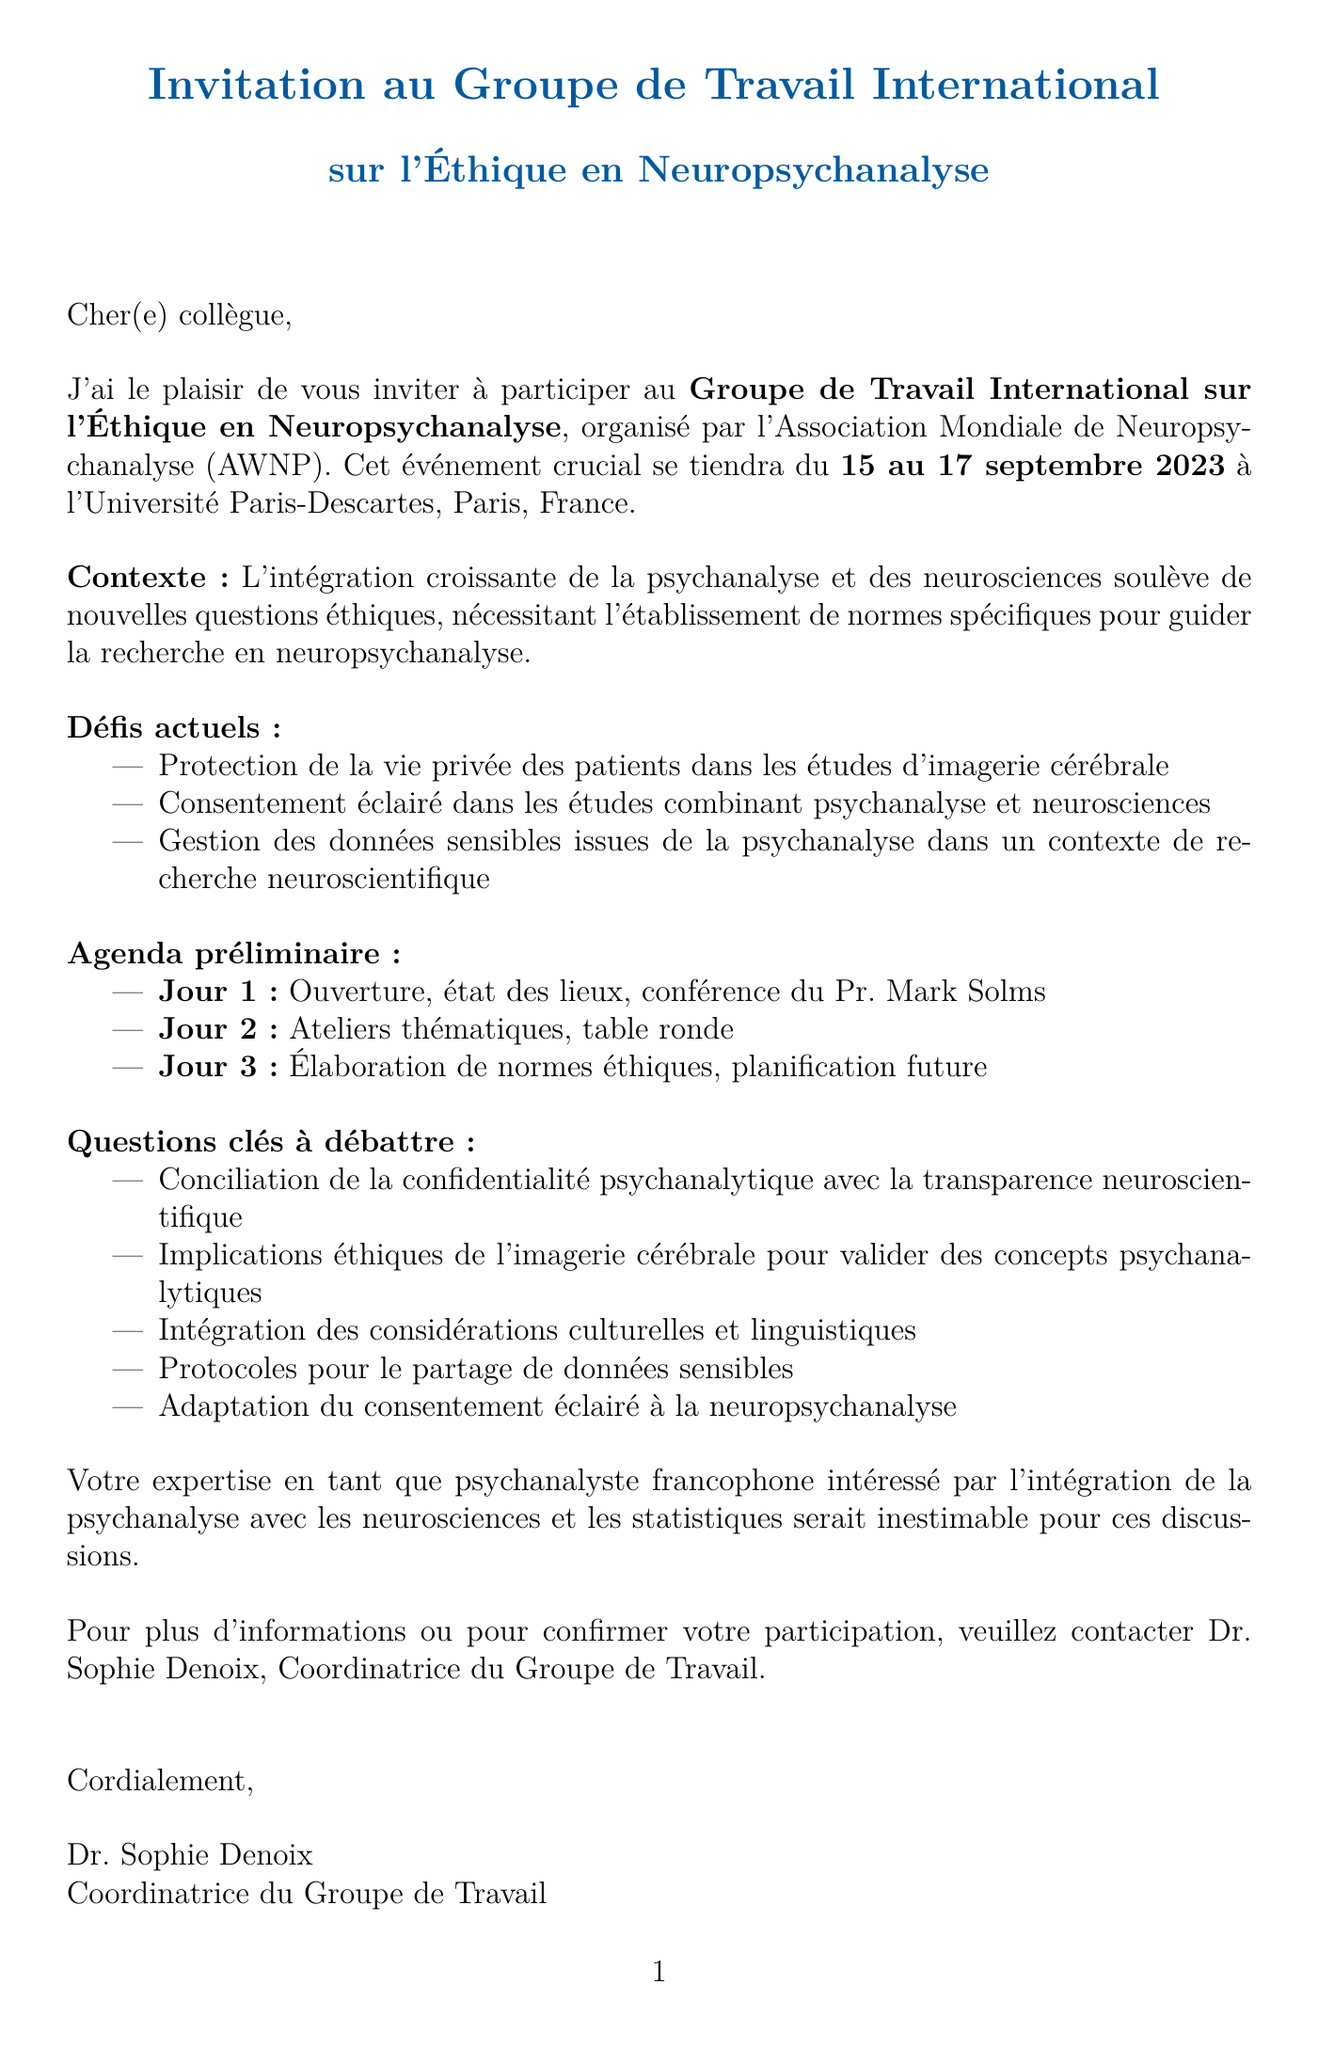Quel est le nom de l'événement ? Le nom de l'événement est mentionné dans le document comme étant le Groupe de Travail International sur l'Éthique en Neuropsychanalyse.
Answer: Groupe de Travail International sur l'Éthique en Neuropsychanalyse Qui est l'organisateur de l'événement ? L'organisateur de l'événement est précisé dans le document, c'est l'Association Mondiale de Neuropsychanalyse (AWNP).
Answer: Association Mondiale de Neuropsychanalyse (AWNP) Quand aura lieu l'événement ? La date de l'événement est spécifiée comme étant du 15 au 17 septembre 2023.
Answer: 15-17 septembre 2023 Quels sont les premiers intervenants lors de la conférence ? Le document mentionne que le Pr. Mark Solms donnera la conférence sur les enjeux éthiques.
Answer: Pr. Mark Solms Quels sont les principaux sujets à débattre ? Les questions à débattre sont listées dans le document et concernent notamment la confidentialité et l'imagerie cérébrale.
Answer: Confidentialité psychanalytique avec transparence neuroscientifique Combien de jours dure l'événement ? La durée de l'événement est explicitement indiquée dans le document comme trois jours.
Answer: Trois jours Qui est la personne à contacter pour plus d'informations ? Le document désigne le Dr. Sophie Denoix comme la personne à contacter.
Answer: Dr. Sophie Denoix Quel est le nom de l'université hôte ? Le document précise que l'événement se tiendra à l'Université Paris-Descartes.
Answer: Université Paris-Descartes Quels types de participants sont attendus ? Le document liste les participants attendus qui incluent des psychanalystes et des neuroscientifiques.
Answer: Psychanalystes et neuroscientifiques 